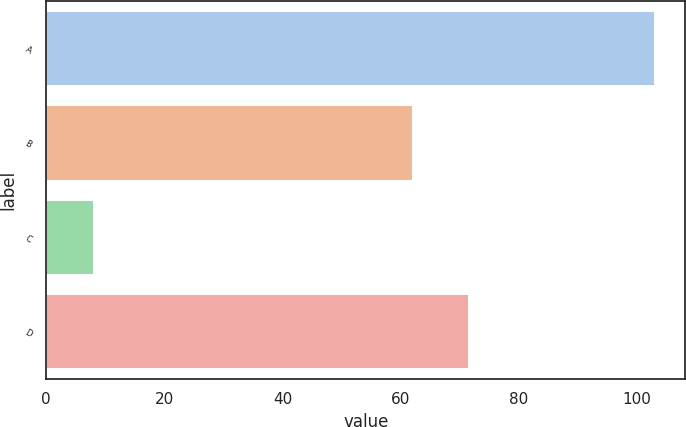Convert chart. <chart><loc_0><loc_0><loc_500><loc_500><bar_chart><fcel>A<fcel>B<fcel>C<fcel>D<nl><fcel>103<fcel>62<fcel>8<fcel>71.5<nl></chart> 